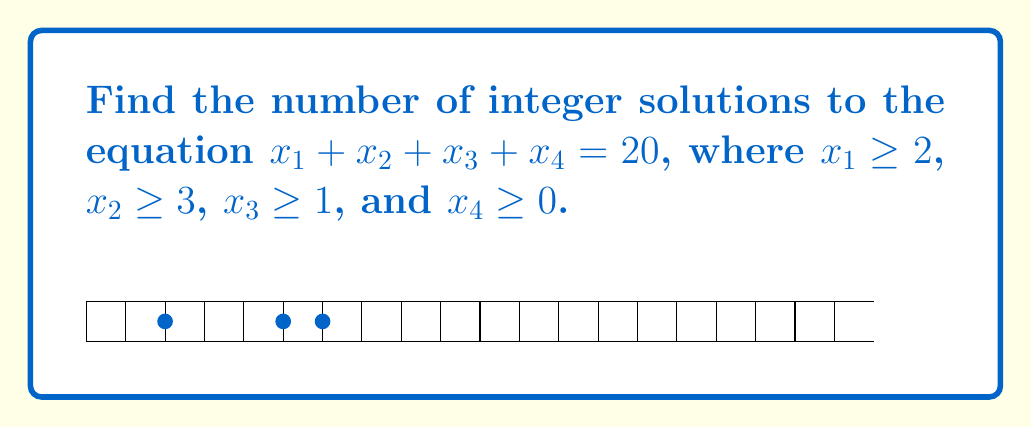Give your solution to this math problem. Let's solve this step-by-step using the stars and bars method:

1) First, we need to transform the equation to remove the constraints:
   Let $y_1 = x_1 - 2$, $y_2 = x_2 - 3$, $y_3 = x_3 - 1$, and $y_4 = x_4$.
   
2) Substituting these into the original equation:
   $(y_1 + 2) + (y_2 + 3) + (y_3 + 1) + y_4 = 20$
   
3) Simplifying:
   $y_1 + y_2 + y_3 + y_4 = 14$
   
4) Now, we need to find the number of non-negative integer solutions to this equation.

5) This is equivalent to distributing 14 identical objects into 4 distinct boxes, which can be solved using the stars and bars method.

6) The number of solutions is given by the combination formula:
   $$\binom{n+k-1}{k-1} = \binom{14+4-1}{4-1} = \binom{17}{3}$$

7) Calculate:
   $$\binom{17}{3} = \frac{17!}{3!(17-3)!} = \frac{17!}{3!14!} = \frac{17 \cdot 16 \cdot 15}{3 \cdot 2 \cdot 1} = 680$$

Therefore, there are 680 integer solutions to the original equation that satisfy the given constraints.
Answer: 680 